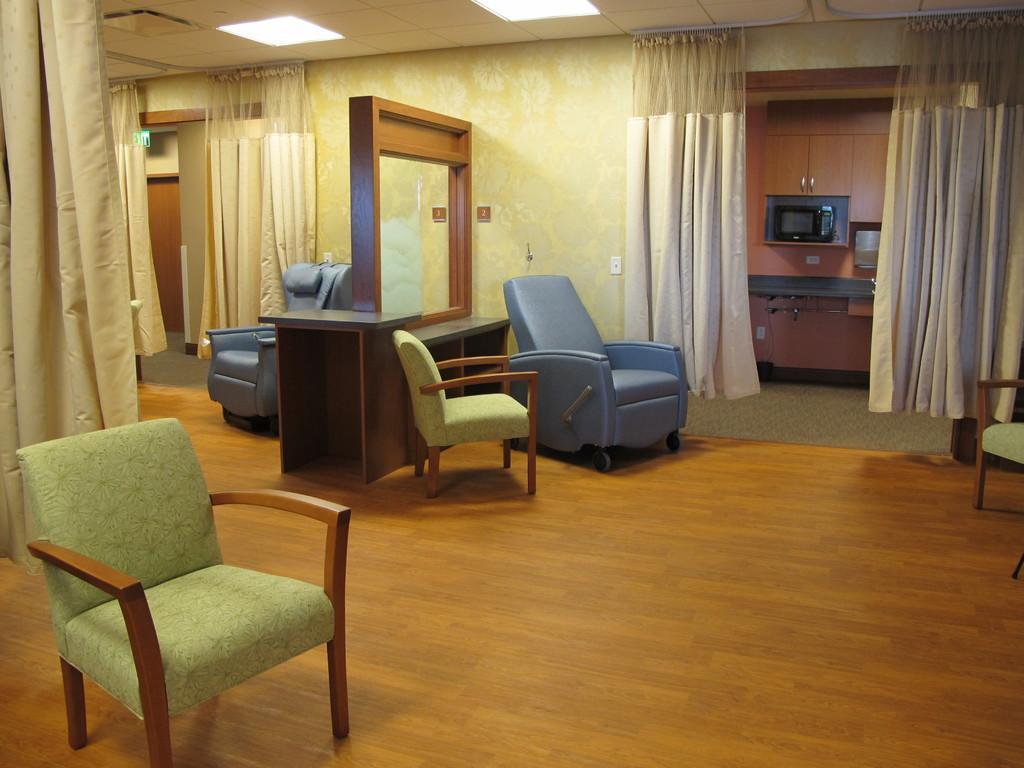Describe this image in one or two sentences. There are chairs and sofa,there are curtains,wall and the light. 